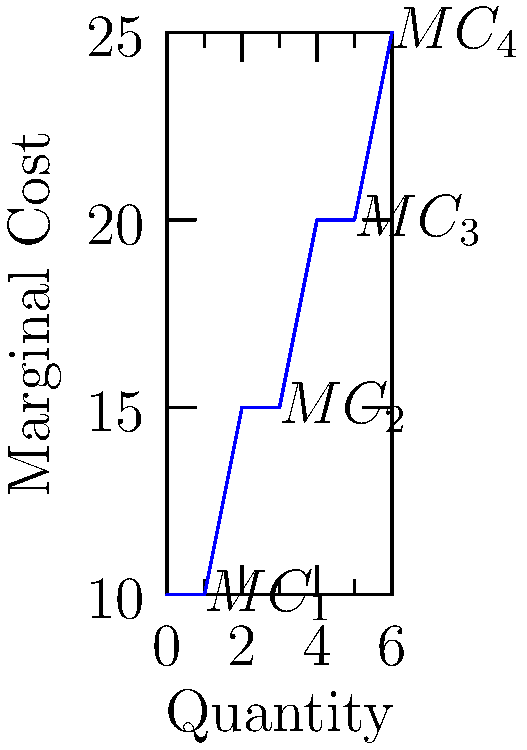Consider the step function graph representing the marginal cost of production for a firm. If the government imposes a per-unit tax of $5 on this product, how would this affect the total cost of producing 5 units? Express your answer as a percentage increase in total cost. To solve this problem, we need to follow these steps:

1) First, calculate the total cost of producing 5 units without the tax:
   - 1st unit: $10
   - 2nd unit: $10
   - 3rd unit: $15
   - 4th unit: $15
   - 5th unit: $20
   Total cost = $10 + $10 + $15 + $15 + $20 = $70

2) Now, calculate the total cost with the $5 per-unit tax:
   - Each unit costs an additional $5
   - New total cost = $70 + (5 * $5) = $95

3) Calculate the percentage increase:
   Percentage increase = $\frac{\text{Increase}}{\text{Original}} \times 100\%$
   = $\frac{95 - 70}{70} \times 100\%$
   = $\frac{25}{70} \times 100\%$
   = $35.71\%$

Therefore, the $5 per-unit tax would increase the total cost of producing 5 units by approximately 35.71%.
Answer: 35.71% 